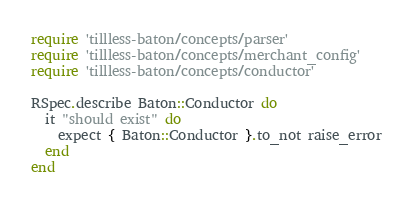<code> <loc_0><loc_0><loc_500><loc_500><_Ruby_>require 'tillless-baton/concepts/parser'
require 'tillless-baton/concepts/merchant_config'
require 'tillless-baton/concepts/conductor'

RSpec.describe Baton::Conductor do
  it "should exist" do
    expect { Baton::Conductor }.to_not raise_error
  end
end
</code> 